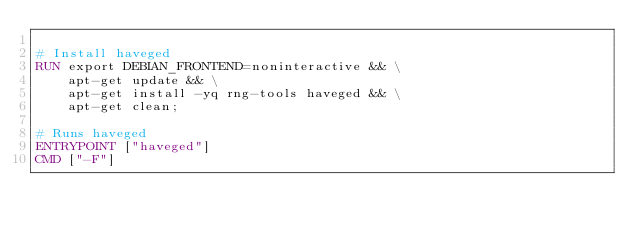<code> <loc_0><loc_0><loc_500><loc_500><_Dockerfile_>
# Install haveged
RUN export DEBIAN_FRONTEND=noninteractive && \
	apt-get update && \
	apt-get install -yq rng-tools haveged && \
	apt-get clean;

# Runs haveged
ENTRYPOINT ["haveged"]
CMD ["-F"]
</code> 